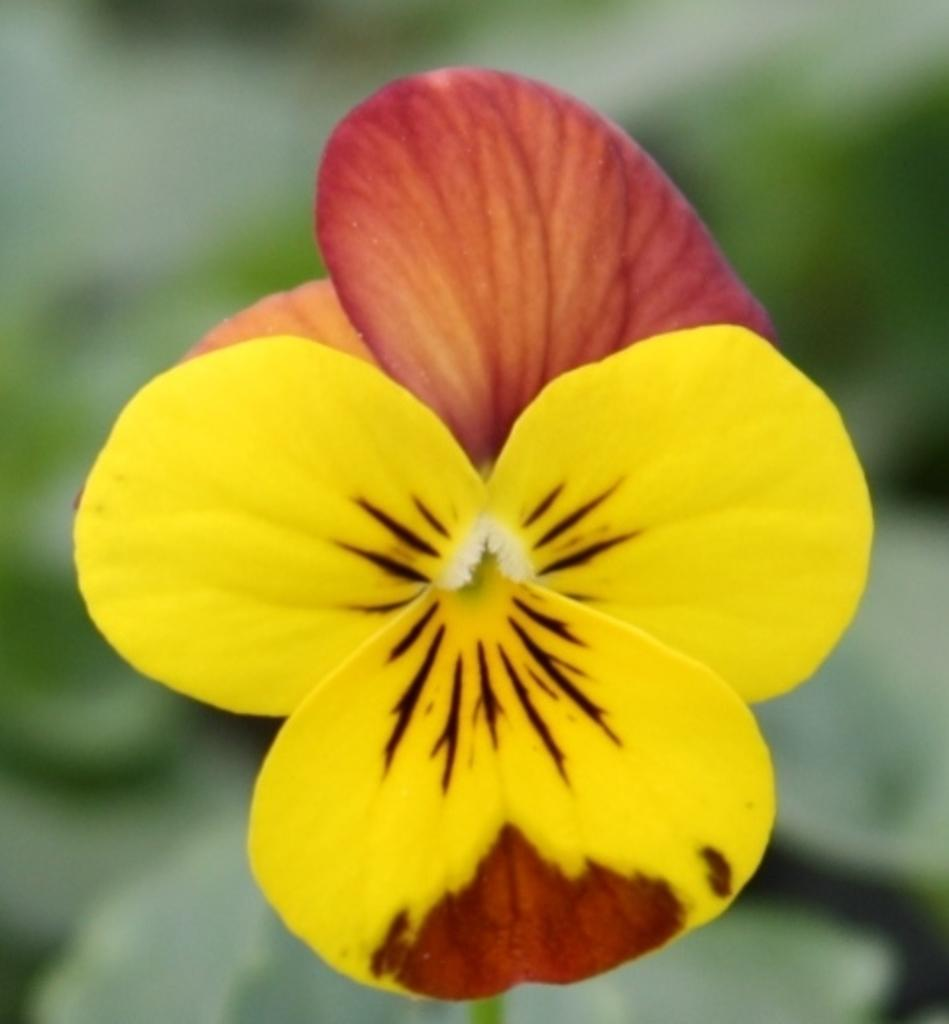What is the main subject of the image? There is a flower in the image. Can you describe the background of the image? The background of the image is blurred. How many dolls are lying on the beds in the image? There are no dolls or beds present in the image; it features a flower with a blurred background. 